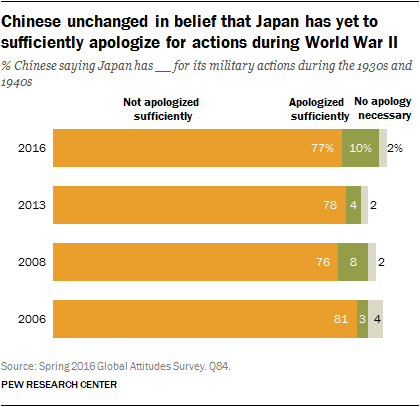Can you explain why there might be variations in the percentages of Chinese citizens who believe no apology is necessary from 2006 to 2016? Variations in the belief that no apology is necessary may be attributed to changes in political climate, diplomatic relations, education on historical matters, generational shifts in perspective, or public sentiment influenced by current events. Each of these factors can contribute to differing views on historical apologies and reconciliation. 